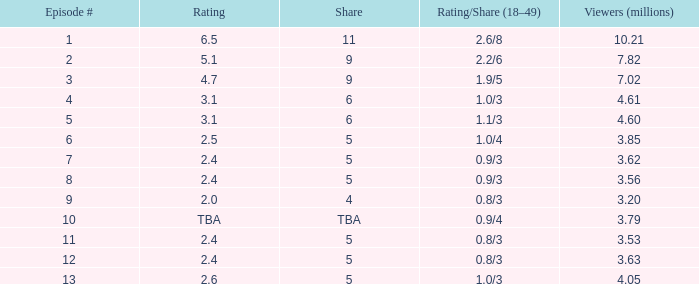What is the average number of million viewers that watched an episode before episode 11 with a share of 4? 3.2. 